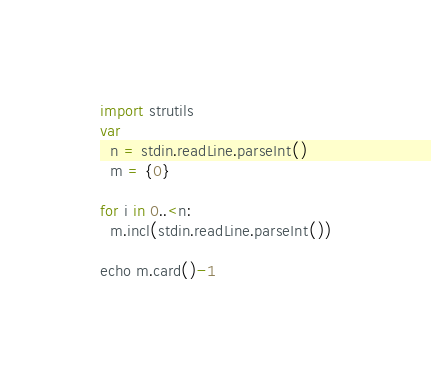Convert code to text. <code><loc_0><loc_0><loc_500><loc_500><_Nim_>import strutils
var
  n = stdin.readLine.parseInt()
  m = {0}

for i in 0..<n:
  m.incl(stdin.readLine.parseInt())

echo m.card()-1

</code> 